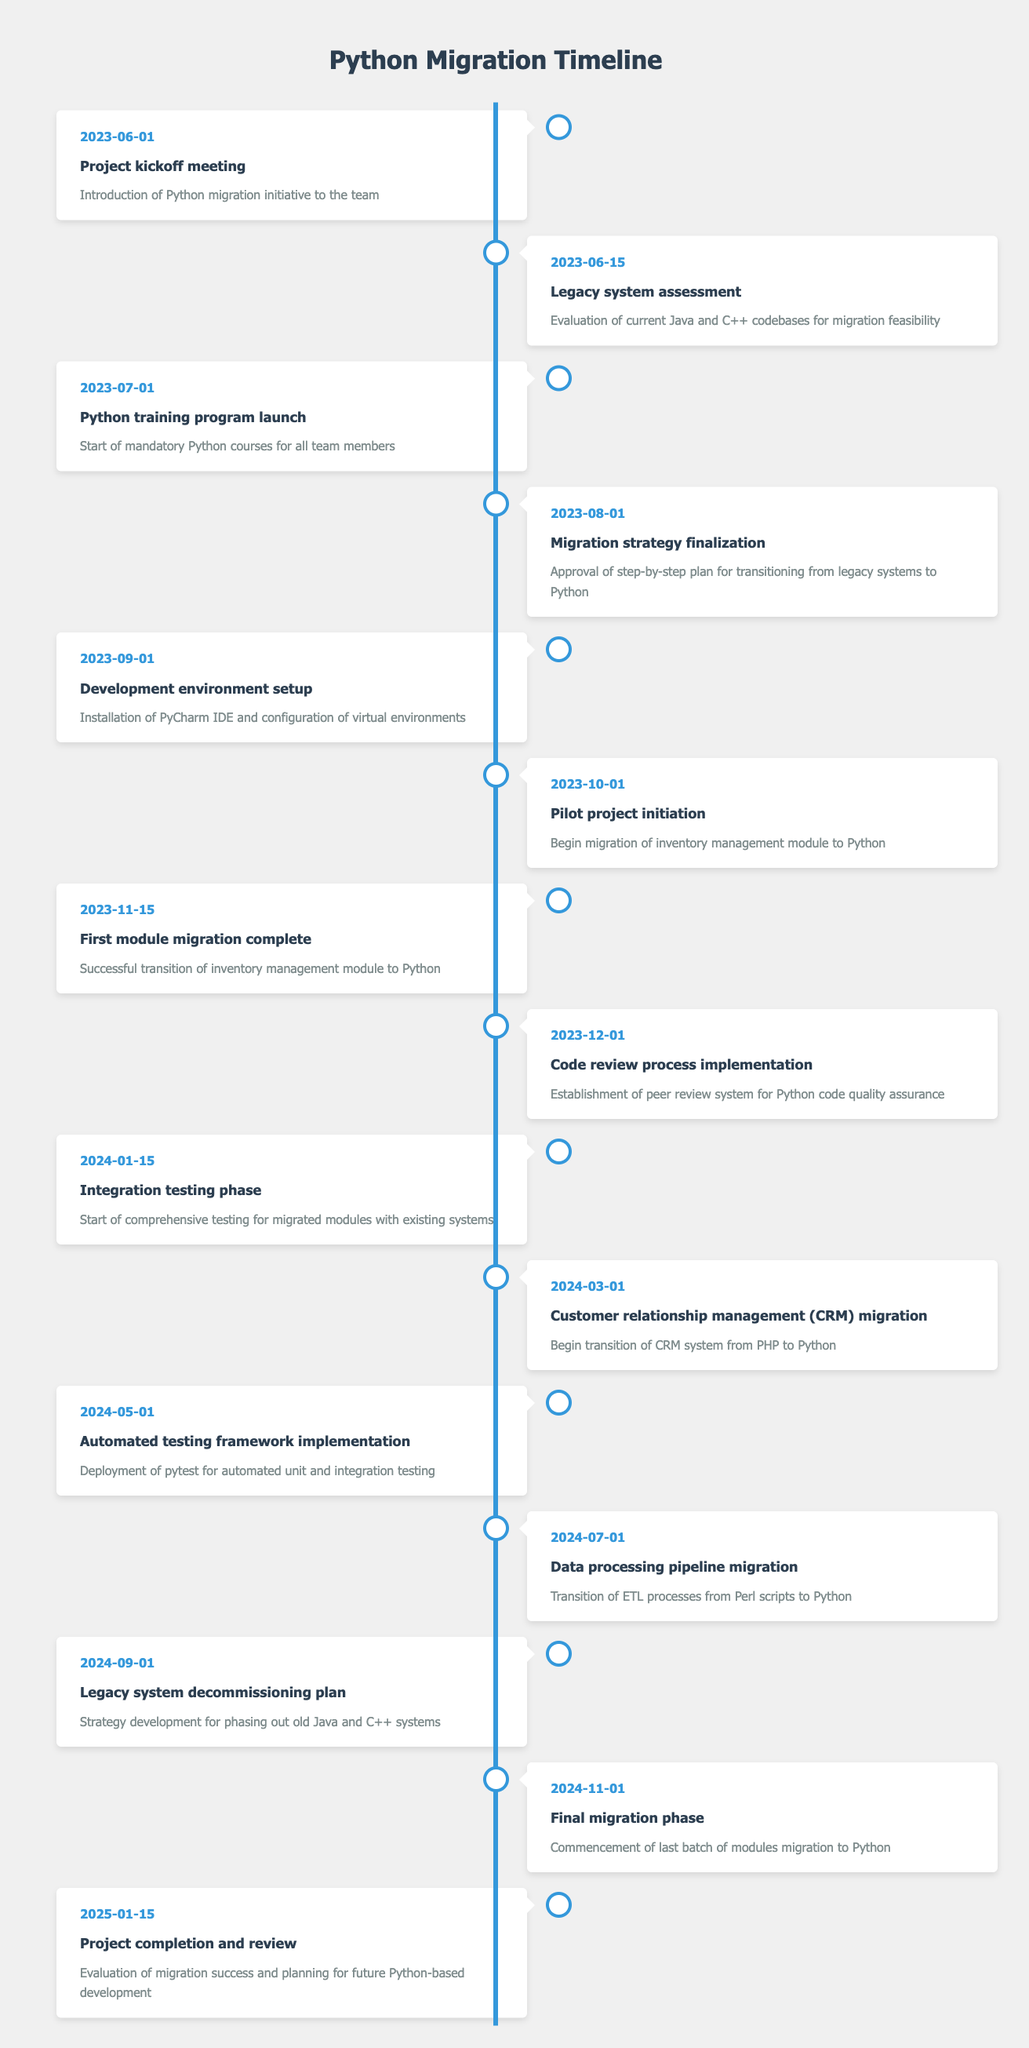What is the date of the project kickoff meeting? The project kickoff meeting is listed in the first row of the timeline, which provides a date of June 1, 2023.
Answer: June 1, 2023 How many milestones are scheduled in 2023? By counting the entries in the timeline for the year 2023, we find there are six milestones: Project kickoff meeting, Legacy system assessment, Python training program launch, Migration strategy finalization, Development environment setup, and Pilot project initiation.
Answer: 6 What milestone is scheduled for October 1, 2023? Looking at the entry for October 1, 2023, the milestone listed is "Pilot project initiation."
Answer: Pilot project initiation Was there a migration strategy finalized before the Python training program launched? The Migration strategy finalization occurred on August 1, 2023, which is after the Python training program launch on July 1, 2023. Thus, the answer is no.
Answer: No What is the average duration between the key milestones in 2023 from kickoff to the last milestone of that year? The key milestones in 2023 are at June 1, June 15, July 1, August 1, September 1, and October 1. These dates span from June 1 to October 1, which is 122 days. There are 5 intervals between 6 milestones, so the average duration is 122/5 = 24.4 days.
Answer: 24.4 days What is the last milestone before the integration testing phase? Checking the timeline, the last milestone before the integration testing phase on January 15, 2024, is "Code review process implementation" on December 1, 2023.
Answer: Code review process implementation How many modules are scheduled for migration in 2024? The milestones for module migration in 2024 include CRM migration, Data processing pipeline migration, and the Final migration phase, totaling three migrations.
Answer: 3 When will the final review of the project take place? The final review of the project is scheduled for January 15, 2025, as mentioned in the last milestone entry.
Answer: January 15, 2025 Is the development environment setup before or after the migration strategy finalization? The development environment setup is scheduled for September 1, 2023, which is after the migration strategy finalization on August 1, 2023. Thus, the answer is after.
Answer: After 